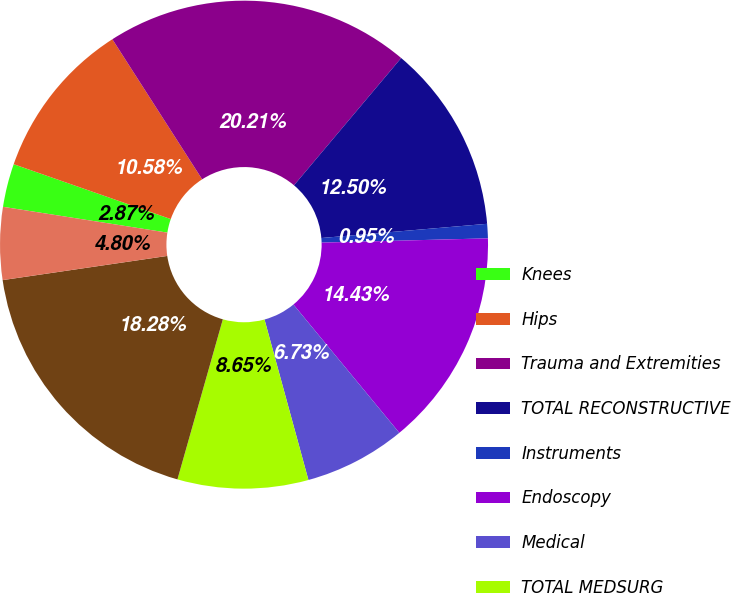<chart> <loc_0><loc_0><loc_500><loc_500><pie_chart><fcel>Knees<fcel>Hips<fcel>Trauma and Extremities<fcel>TOTAL RECONSTRUCTIVE<fcel>Instruments<fcel>Endoscopy<fcel>Medical<fcel>TOTAL MEDSURG<fcel>Neurotechnology<fcel>Spine<nl><fcel>2.87%<fcel>10.58%<fcel>20.21%<fcel>12.5%<fcel>0.95%<fcel>14.43%<fcel>6.73%<fcel>8.65%<fcel>18.28%<fcel>4.8%<nl></chart> 